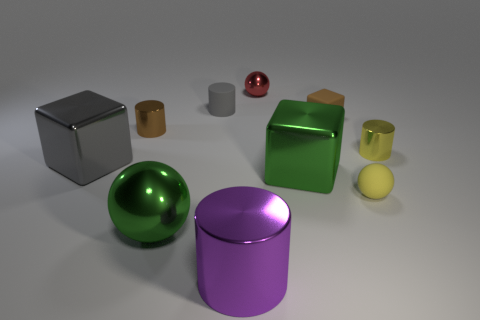How many cylinders are either yellow matte things or tiny brown objects?
Provide a succinct answer. 1. How many large rubber cubes are there?
Your response must be concise. 0. What is the size of the metallic object behind the brown metallic cylinder that is behind the large green metal sphere?
Give a very brief answer. Small. What number of other things are the same size as the yellow matte sphere?
Your response must be concise. 5. There is a large purple thing; how many large green blocks are in front of it?
Provide a succinct answer. 0. The brown shiny cylinder is what size?
Make the answer very short. Small. Is the yellow object on the left side of the yellow cylinder made of the same material as the small yellow thing behind the matte sphere?
Keep it short and to the point. No. Is there a small matte cylinder that has the same color as the small cube?
Provide a short and direct response. No. What is the color of the rubber sphere that is the same size as the brown matte thing?
Your answer should be very brief. Yellow. There is a big block that is to the right of the green shiny ball; does it have the same color as the small matte ball?
Offer a very short reply. No. 